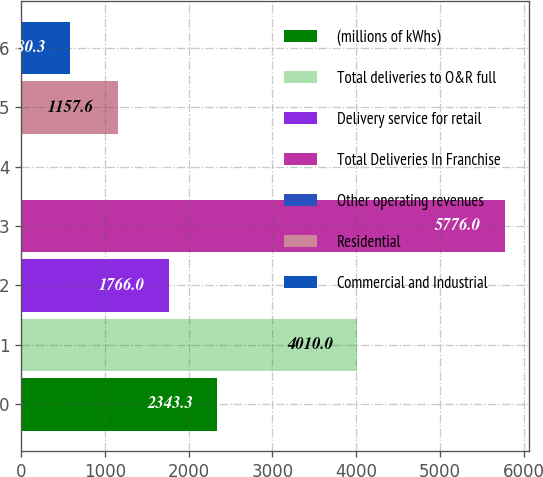Convert chart to OTSL. <chart><loc_0><loc_0><loc_500><loc_500><bar_chart><fcel>(millions of kWhs)<fcel>Total deliveries to O&R full<fcel>Delivery service for retail<fcel>Total Deliveries In Franchise<fcel>Other operating revenues<fcel>Residential<fcel>Commercial and Industrial<nl><fcel>2343.3<fcel>4010<fcel>1766<fcel>5776<fcel>3<fcel>1157.6<fcel>580.3<nl></chart> 